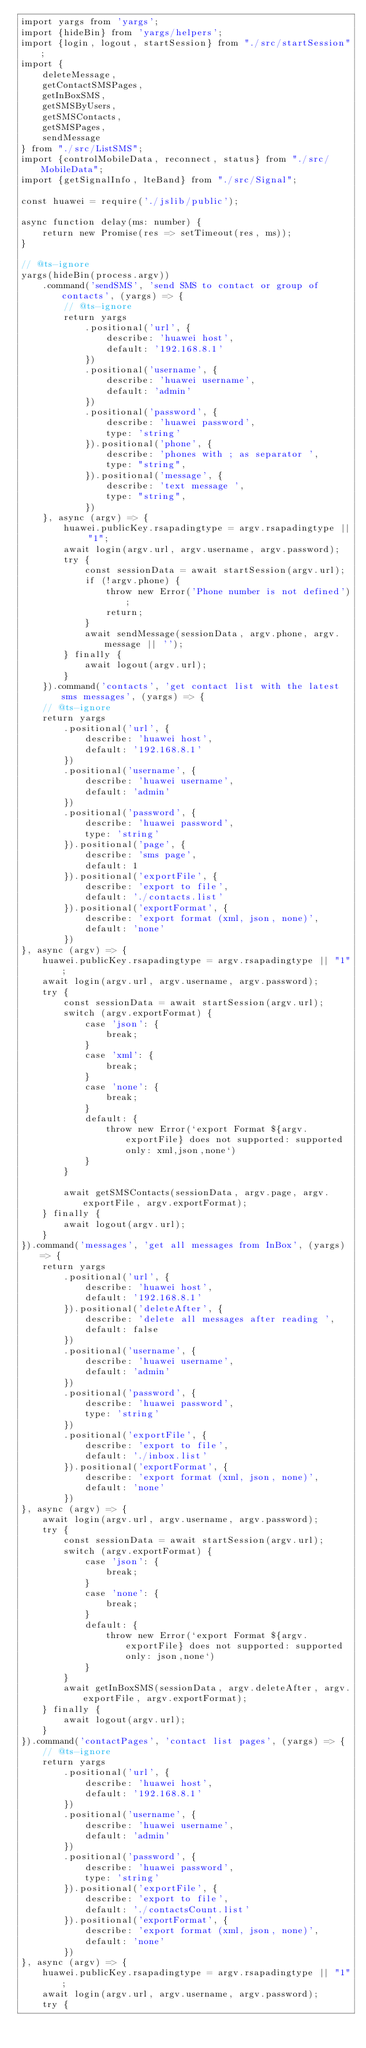Convert code to text. <code><loc_0><loc_0><loc_500><loc_500><_TypeScript_>import yargs from 'yargs';
import {hideBin} from 'yargs/helpers';
import {login, logout, startSession} from "./src/startSession";
import {
    deleteMessage,
    getContactSMSPages,
    getInBoxSMS,
    getSMSByUsers,
    getSMSContacts,
    getSMSPages,
    sendMessage
} from "./src/ListSMS";
import {controlMobileData, reconnect, status} from "./src/MobileData";
import {getSignalInfo, lteBand} from "./src/Signal";

const huawei = require('./jslib/public');

async function delay(ms: number) {
    return new Promise(res => setTimeout(res, ms));
}

// @ts-ignore
yargs(hideBin(process.argv))
    .command('sendSMS', 'send SMS to contact or group of contacts', (yargs) => {
        // @ts-ignore
        return yargs
            .positional('url', {
                describe: 'huawei host',
                default: '192.168.8.1'
            })
            .positional('username', {
                describe: 'huawei username',
                default: 'admin'
            })
            .positional('password', {
                describe: 'huawei password',
                type: 'string'
            }).positional('phone', {
                describe: 'phones with ; as separator ',
                type: "string",
            }).positional('message', {
                describe: 'text message ',
                type: "string",
            })
    }, async (argv) => {
        huawei.publicKey.rsapadingtype = argv.rsapadingtype || "1";
        await login(argv.url, argv.username, argv.password);
        try {
            const sessionData = await startSession(argv.url);
            if (!argv.phone) {
                throw new Error('Phone number is not defined');
                return;
            }
            await sendMessage(sessionData, argv.phone, argv.message || '');
        } finally {
            await logout(argv.url);
        }
    }).command('contacts', 'get contact list with the latest sms messages', (yargs) => {
    // @ts-ignore
    return yargs
        .positional('url', {
            describe: 'huawei host',
            default: '192.168.8.1'
        })
        .positional('username', {
            describe: 'huawei username',
            default: 'admin'
        })
        .positional('password', {
            describe: 'huawei password',
            type: 'string'
        }).positional('page', {
            describe: 'sms page',
            default: 1
        }).positional('exportFile', {
            describe: 'export to file',
            default: './contacts.list'
        }).positional('exportFormat', {
            describe: 'export format (xml, json, none)',
            default: 'none'
        })
}, async (argv) => {
    huawei.publicKey.rsapadingtype = argv.rsapadingtype || "1";
    await login(argv.url, argv.username, argv.password);
    try {
        const sessionData = await startSession(argv.url);
        switch (argv.exportFormat) {
            case 'json': {
                break;
            }
            case 'xml': {
                break;
            }
            case 'none': {
                break;
            }
            default: {
                throw new Error(`export Format ${argv.exportFile} does not supported: supported only: xml,json,none`)
            }
        }

        await getSMSContacts(sessionData, argv.page, argv.exportFile, argv.exportFormat);
    } finally {
        await logout(argv.url);
    }
}).command('messages', 'get all messages from InBox', (yargs) => {
    return yargs
        .positional('url', {
            describe: 'huawei host',
            default: '192.168.8.1'
        }).positional('deleteAfter', {
            describe: 'delete all messages after reading ',
            default: false
        })
        .positional('username', {
            describe: 'huawei username',
            default: 'admin'
        })
        .positional('password', {
            describe: 'huawei password',
            type: 'string'
        })
        .positional('exportFile', {
            describe: 'export to file',
            default: './inbox.list'
        }).positional('exportFormat', {
            describe: 'export format (xml, json, none)',
            default: 'none'
        })
}, async (argv) => {
    await login(argv.url, argv.username, argv.password);
    try {
        const sessionData = await startSession(argv.url);
        switch (argv.exportFormat) {
            case 'json': {
                break;
            }
            case 'none': {
                break;
            }
            default: {
                throw new Error(`export Format ${argv.exportFile} does not supported: supported only: json,none`)
            }
        }
        await getInBoxSMS(sessionData, argv.deleteAfter, argv.exportFile, argv.exportFormat);
    } finally {
        await logout(argv.url);
    }
}).command('contactPages', 'contact list pages', (yargs) => {
    // @ts-ignore
    return yargs
        .positional('url', {
            describe: 'huawei host',
            default: '192.168.8.1'
        })
        .positional('username', {
            describe: 'huawei username',
            default: 'admin'
        })
        .positional('password', {
            describe: 'huawei password',
            type: 'string'
        }).positional('exportFile', {
            describe: 'export to file',
            default: './contactsCount.list'
        }).positional('exportFormat', {
            describe: 'export format (xml, json, none)',
            default: 'none'
        })
}, async (argv) => {
    huawei.publicKey.rsapadingtype = argv.rsapadingtype || "1";
    await login(argv.url, argv.username, argv.password);
    try {</code> 